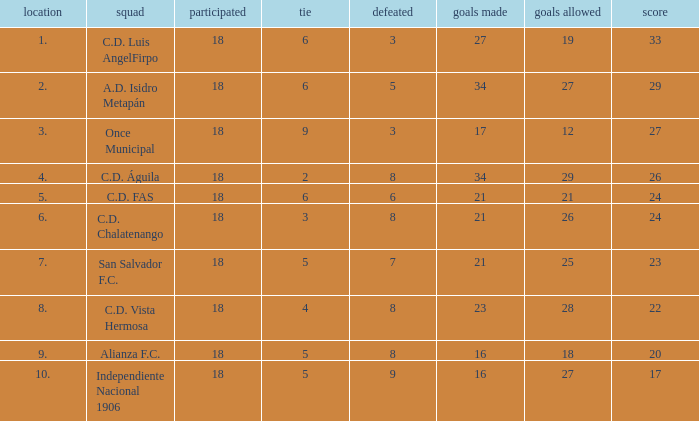What's the place that Once Municipal has a lost greater than 3? None. 